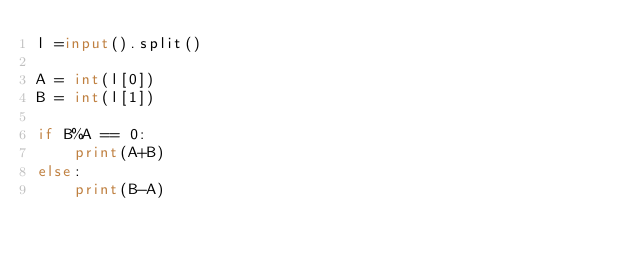Convert code to text. <code><loc_0><loc_0><loc_500><loc_500><_Python_>l =input().split()

A = int(l[0])
B = int(l[1])

if B%A == 0:
    print(A+B)
else:
    print(B-A)
    </code> 